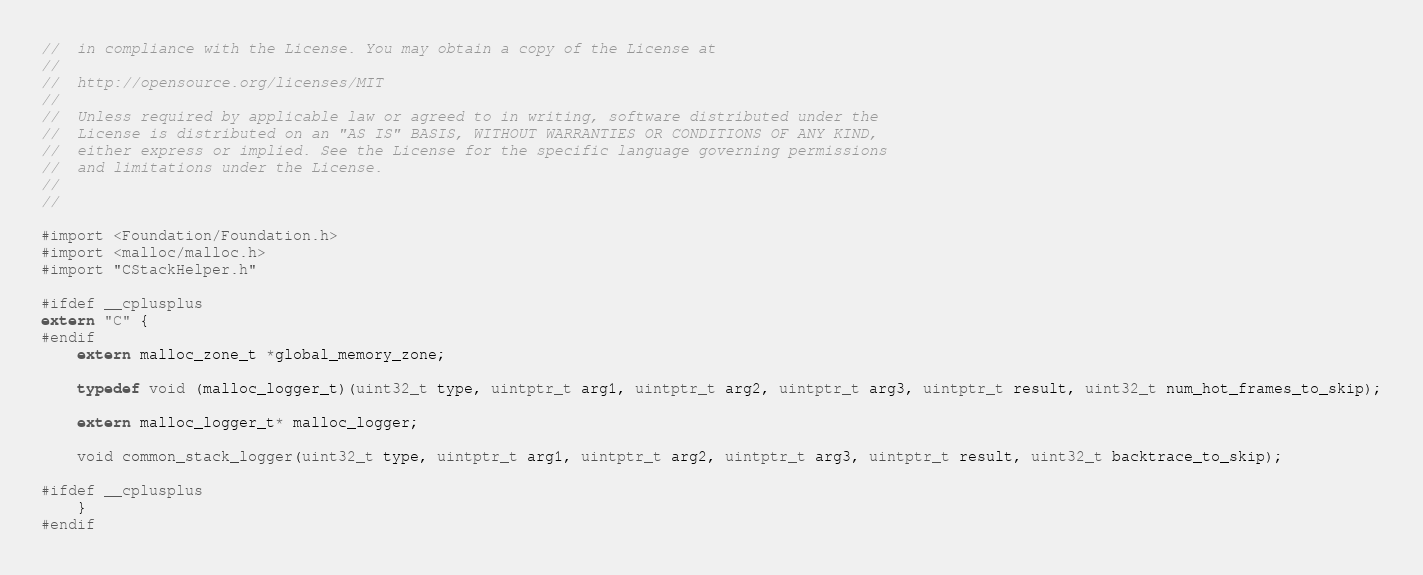Convert code to text. <code><loc_0><loc_0><loc_500><loc_500><_C_>//  in compliance with the License. You may obtain a copy of the License at
//
//  http://opensource.org/licenses/MIT
//
//  Unless required by applicable law or agreed to in writing, software distributed under the
//  License is distributed on an "AS IS" BASIS, WITHOUT WARRANTIES OR CONDITIONS OF ANY KIND,
//  either express or implied. See the License for the specific language governing permissions
//  and limitations under the License.
//
//

#import <Foundation/Foundation.h>
#import <malloc/malloc.h>
#import "CStackHelper.h"

#ifdef __cplusplus
extern "C" {
#endif
    extern malloc_zone_t *global_memory_zone;
    
    typedef void (malloc_logger_t)(uint32_t type, uintptr_t arg1, uintptr_t arg2, uintptr_t arg3, uintptr_t result, uint32_t num_hot_frames_to_skip);
    
    extern malloc_logger_t* malloc_logger;
    
    void common_stack_logger(uint32_t type, uintptr_t arg1, uintptr_t arg2, uintptr_t arg3, uintptr_t result, uint32_t backtrace_to_skip);
    
#ifdef __cplusplus
    }
#endif
</code> 